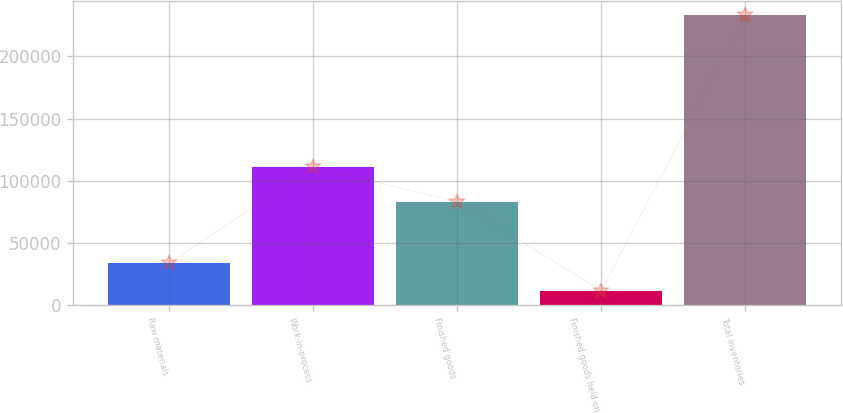<chart> <loc_0><loc_0><loc_500><loc_500><bar_chart><fcel>Raw materials<fcel>Work-in-process<fcel>Finished goods<fcel>Finished goods held on<fcel>Total inventories<nl><fcel>33662.7<fcel>111190<fcel>83037<fcel>11523<fcel>232920<nl></chart> 